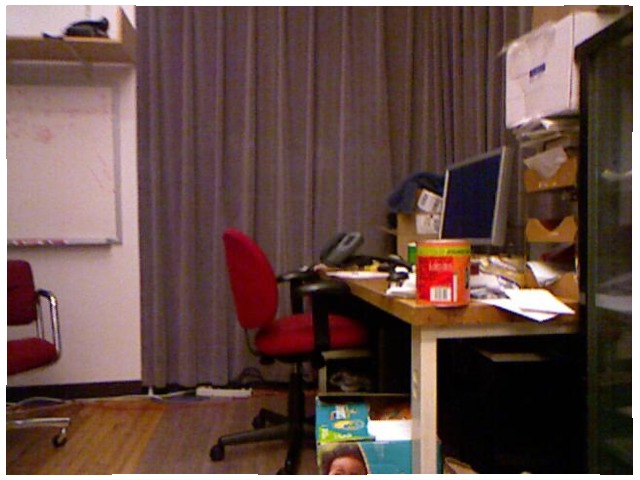<image>
Is the box in front of the chair? Yes. The box is positioned in front of the chair, appearing closer to the camera viewpoint. Is there a red chair in front of the monitor? Yes. The red chair is positioned in front of the monitor, appearing closer to the camera viewpoint. Is the box above the screen? Yes. The box is positioned above the screen in the vertical space, higher up in the scene. 